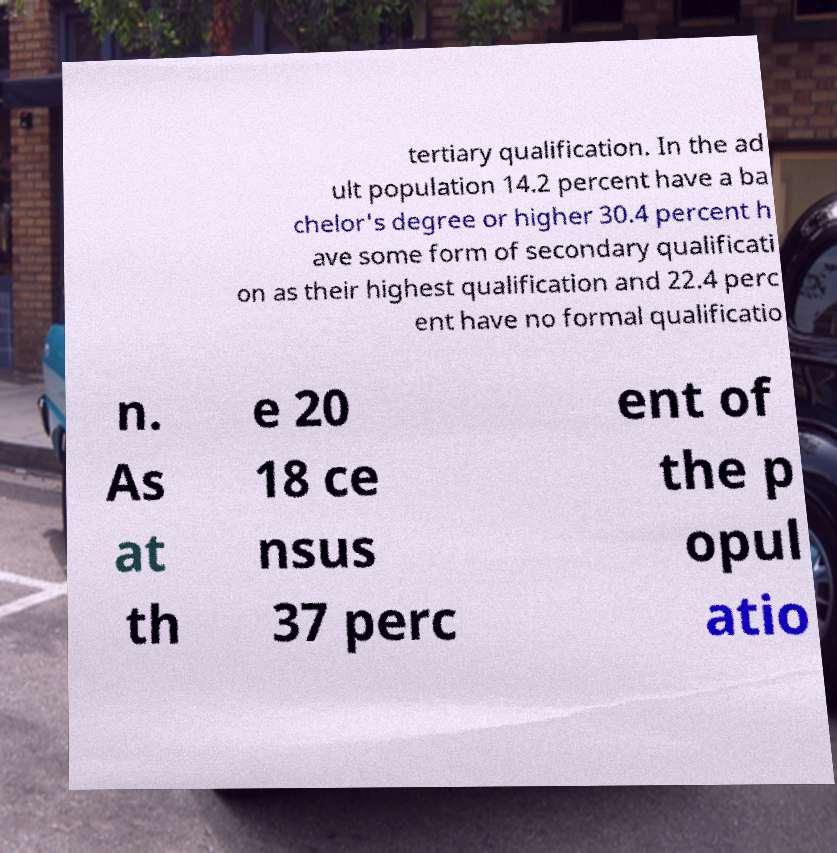There's text embedded in this image that I need extracted. Can you transcribe it verbatim? tertiary qualification. In the ad ult population 14.2 percent have a ba chelor's degree or higher 30.4 percent h ave some form of secondary qualificati on as their highest qualification and 22.4 perc ent have no formal qualificatio n. As at th e 20 18 ce nsus 37 perc ent of the p opul atio 